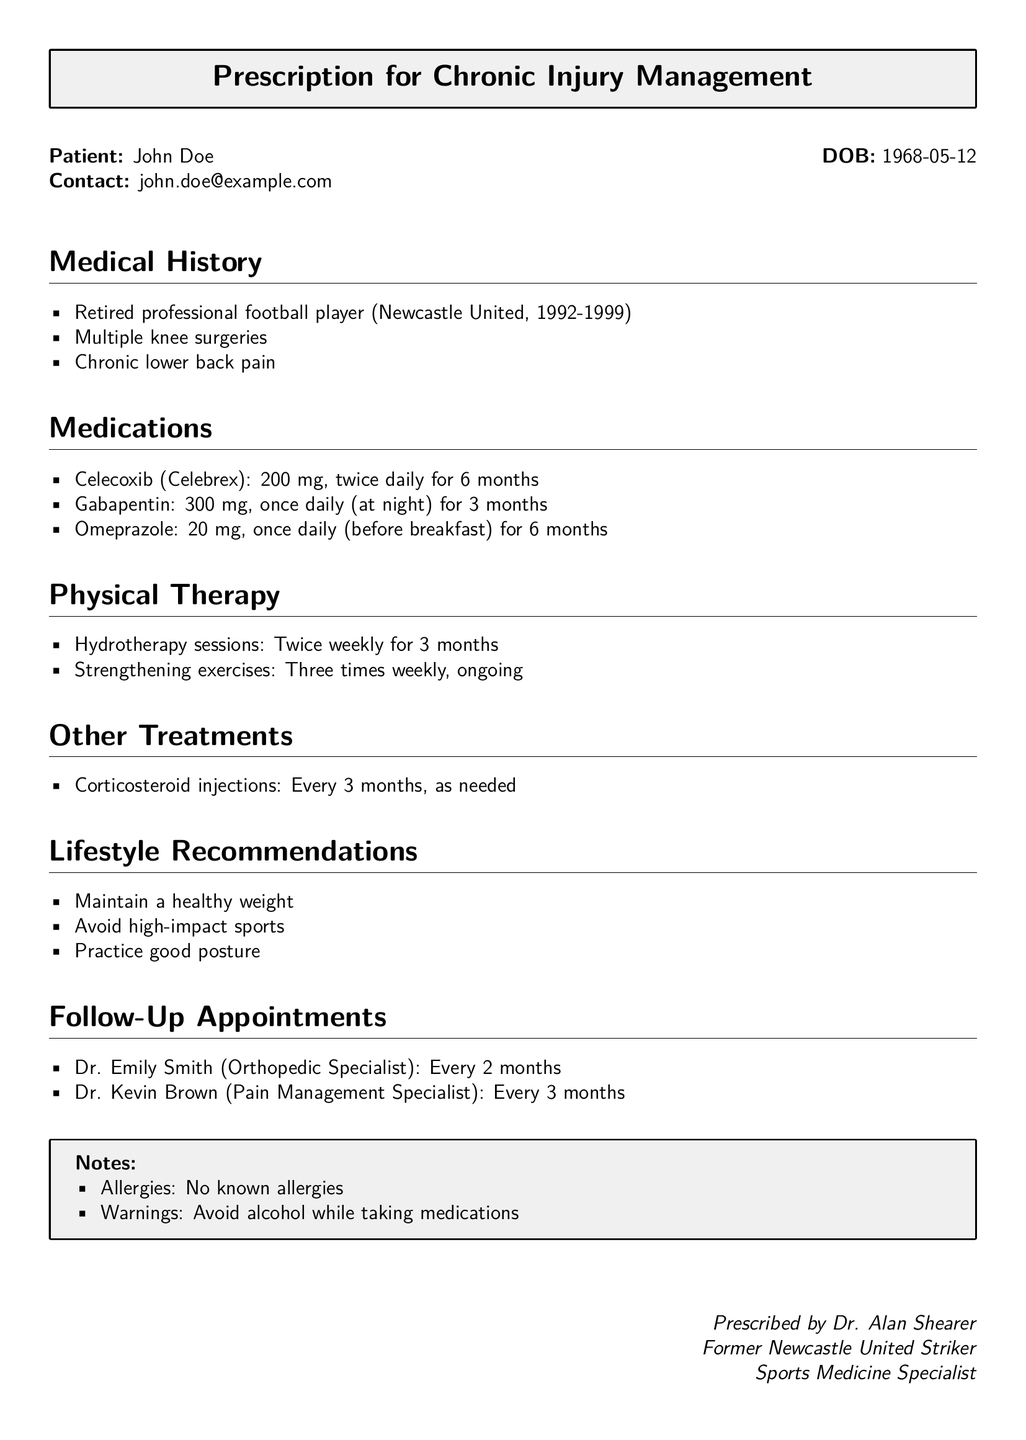What is the patient's name? The patient's name is stated at the top of the document.
Answer: John Doe How often should Celecoxib be taken? The medication schedule specifies the frequency of Celecoxib intake.
Answer: Twice daily What is the dosage of Gabapentin? The document specifies the amount for each medication.
Answer: 300 mg When is the next appointment with Dr. Emily Smith? The follow-up appointments section lists the schedule for visits with specialists.
Answer: Every 2 months How many hydrotherapy sessions are prescribed per week? The physical therapy section provides the frequency of hydrotherapy sessions.
Answer: Twice weekly What lifestyle recommendation is given concerning sports? The lifestyle recommendations highlight specific activity restrictions.
Answer: Avoid high-impact sports What is the frequency of corticosteroid injections? The document mentions the administration schedule for corticosteroid injections.
Answer: Every 3 months Who prescribed the medications? The prescribed by section identifies the healthcare provider responsible for the prescription.
Answer: Dr. Alan Shearer 